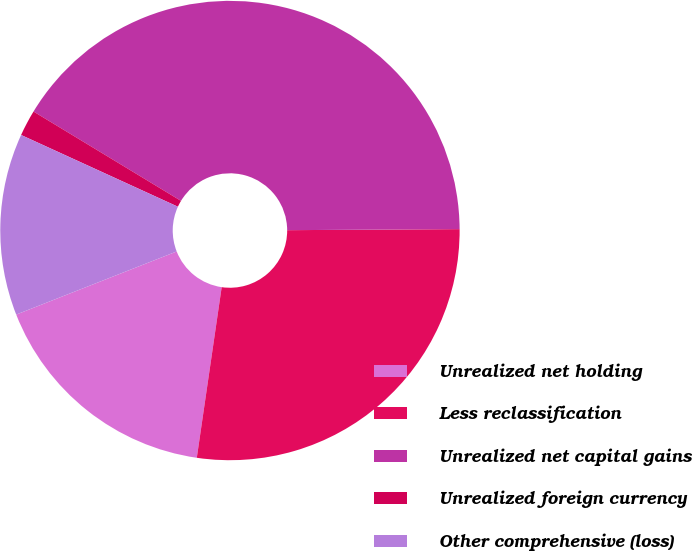<chart> <loc_0><loc_0><loc_500><loc_500><pie_chart><fcel>Unrealized net holding<fcel>Less reclassification<fcel>Unrealized net capital gains<fcel>Unrealized foreign currency<fcel>Other comprehensive (loss)<nl><fcel>16.73%<fcel>27.4%<fcel>41.23%<fcel>1.84%<fcel>12.79%<nl></chart> 